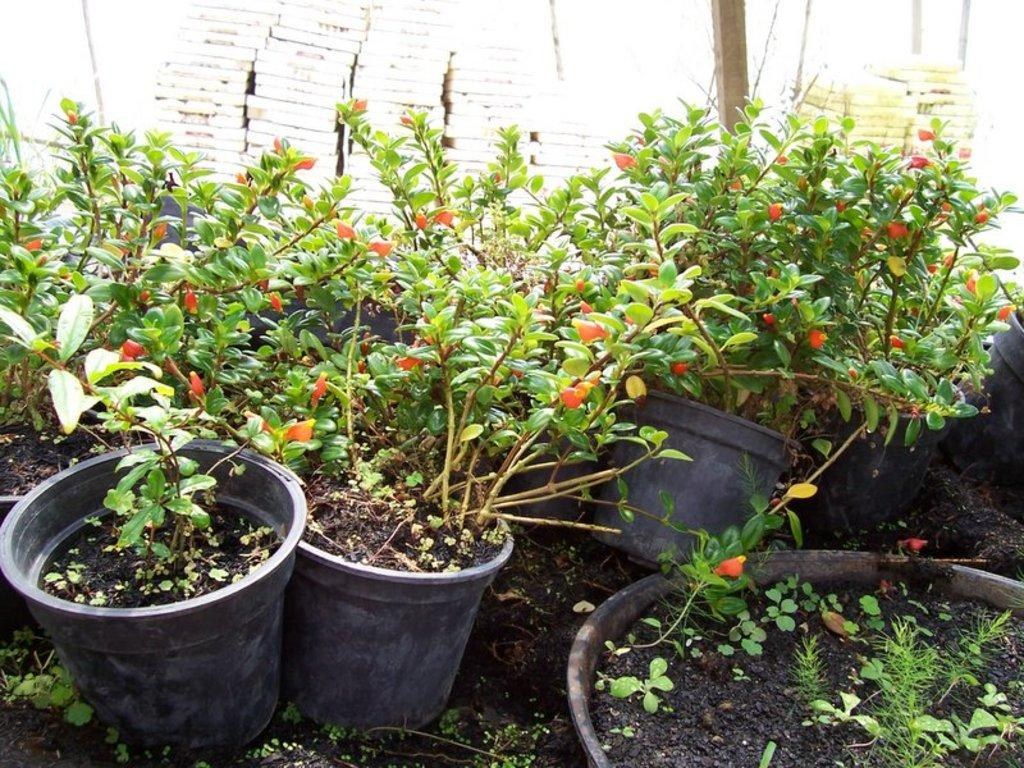What type of plants can be seen in the image? There are house plants in the image. What stage of growth are the plants in? There are buds in the image, indicating that the plants are in the early stages of growth. What word is causing the plants to grow in the image? There is no specific word causing the plants to grow in the image; the growth is a natural process. 